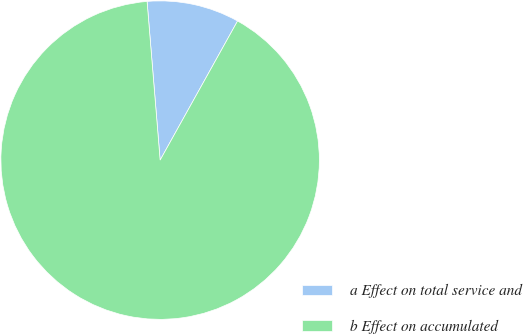Convert chart to OTSL. <chart><loc_0><loc_0><loc_500><loc_500><pie_chart><fcel>a Effect on total service and<fcel>b Effect on accumulated<nl><fcel>9.39%<fcel>90.61%<nl></chart> 